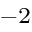Convert formula to latex. <formula><loc_0><loc_0><loc_500><loc_500>^ { - 2 }</formula> 